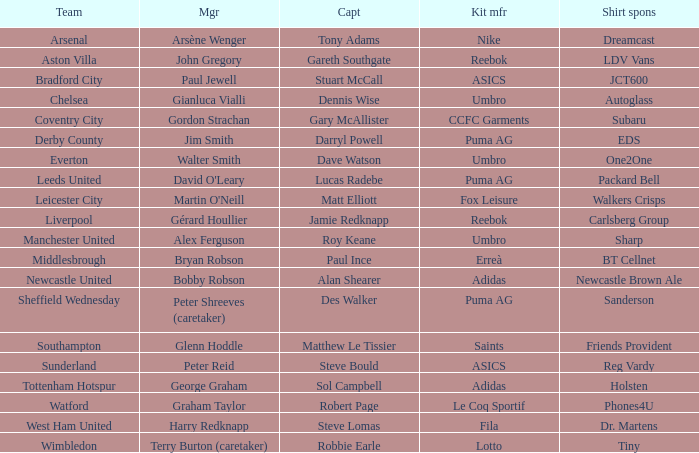Help me parse the entirety of this table. {'header': ['Team', 'Mgr', 'Capt', 'Kit mfr', 'Shirt spons'], 'rows': [['Arsenal', 'Arsène Wenger', 'Tony Adams', 'Nike', 'Dreamcast'], ['Aston Villa', 'John Gregory', 'Gareth Southgate', 'Reebok', 'LDV Vans'], ['Bradford City', 'Paul Jewell', 'Stuart McCall', 'ASICS', 'JCT600'], ['Chelsea', 'Gianluca Vialli', 'Dennis Wise', 'Umbro', 'Autoglass'], ['Coventry City', 'Gordon Strachan', 'Gary McAllister', 'CCFC Garments', 'Subaru'], ['Derby County', 'Jim Smith', 'Darryl Powell', 'Puma AG', 'EDS'], ['Everton', 'Walter Smith', 'Dave Watson', 'Umbro', 'One2One'], ['Leeds United', "David O'Leary", 'Lucas Radebe', 'Puma AG', 'Packard Bell'], ['Leicester City', "Martin O'Neill", 'Matt Elliott', 'Fox Leisure', 'Walkers Crisps'], ['Liverpool', 'Gérard Houllier', 'Jamie Redknapp', 'Reebok', 'Carlsberg Group'], ['Manchester United', 'Alex Ferguson', 'Roy Keane', 'Umbro', 'Sharp'], ['Middlesbrough', 'Bryan Robson', 'Paul Ince', 'Erreà', 'BT Cellnet'], ['Newcastle United', 'Bobby Robson', 'Alan Shearer', 'Adidas', 'Newcastle Brown Ale'], ['Sheffield Wednesday', 'Peter Shreeves (caretaker)', 'Des Walker', 'Puma AG', 'Sanderson'], ['Southampton', 'Glenn Hoddle', 'Matthew Le Tissier', 'Saints', 'Friends Provident'], ['Sunderland', 'Peter Reid', 'Steve Bould', 'ASICS', 'Reg Vardy'], ['Tottenham Hotspur', 'George Graham', 'Sol Campbell', 'Adidas', 'Holsten'], ['Watford', 'Graham Taylor', 'Robert Page', 'Le Coq Sportif', 'Phones4U'], ['West Ham United', 'Harry Redknapp', 'Steve Lomas', 'Fila', 'Dr. Martens'], ['Wimbledon', 'Terry Burton (caretaker)', 'Robbie Earle', 'Lotto', 'Tiny']]} Which Kit Manufacturer supports team Everton? Umbro. 